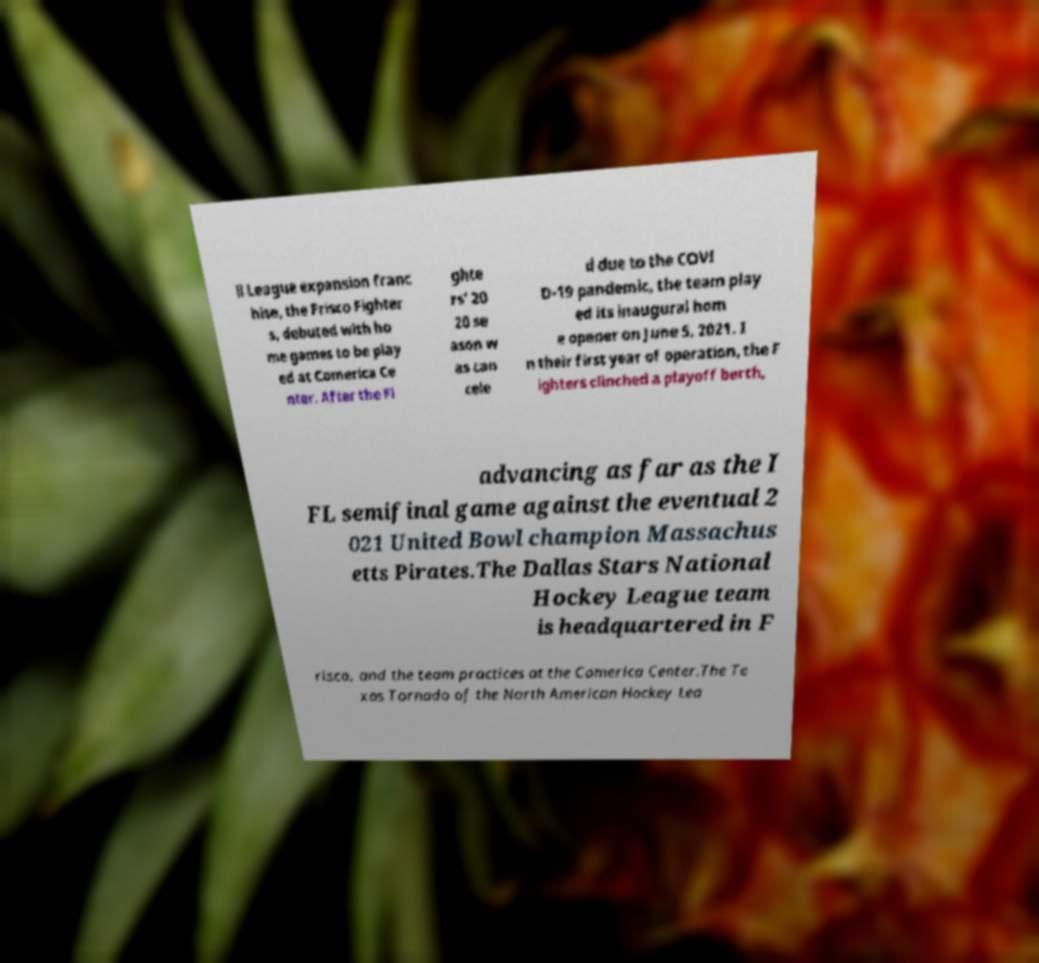Could you extract and type out the text from this image? ll League expansion franc hise, the Frisco Fighter s, debuted with ho me games to be play ed at Comerica Ce nter. After the Fi ghte rs' 20 20 se ason w as can cele d due to the COVI D-19 pandemic, the team play ed its inaugural hom e opener on June 5, 2021. I n their first year of operation, the F ighters clinched a playoff berth, advancing as far as the I FL semifinal game against the eventual 2 021 United Bowl champion Massachus etts Pirates.The Dallas Stars National Hockey League team is headquartered in F risco, and the team practices at the Comerica Center.The Te xas Tornado of the North American Hockey Lea 